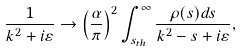<formula> <loc_0><loc_0><loc_500><loc_500>\frac { 1 } { k ^ { 2 } + i \varepsilon } \rightarrow \left ( \frac { \alpha } { \pi } \right ) ^ { 2 } \int _ { s _ { t h } } ^ { \infty } \frac { \rho ( s ) d s } { k ^ { 2 } - s + i \varepsilon } ,</formula> 